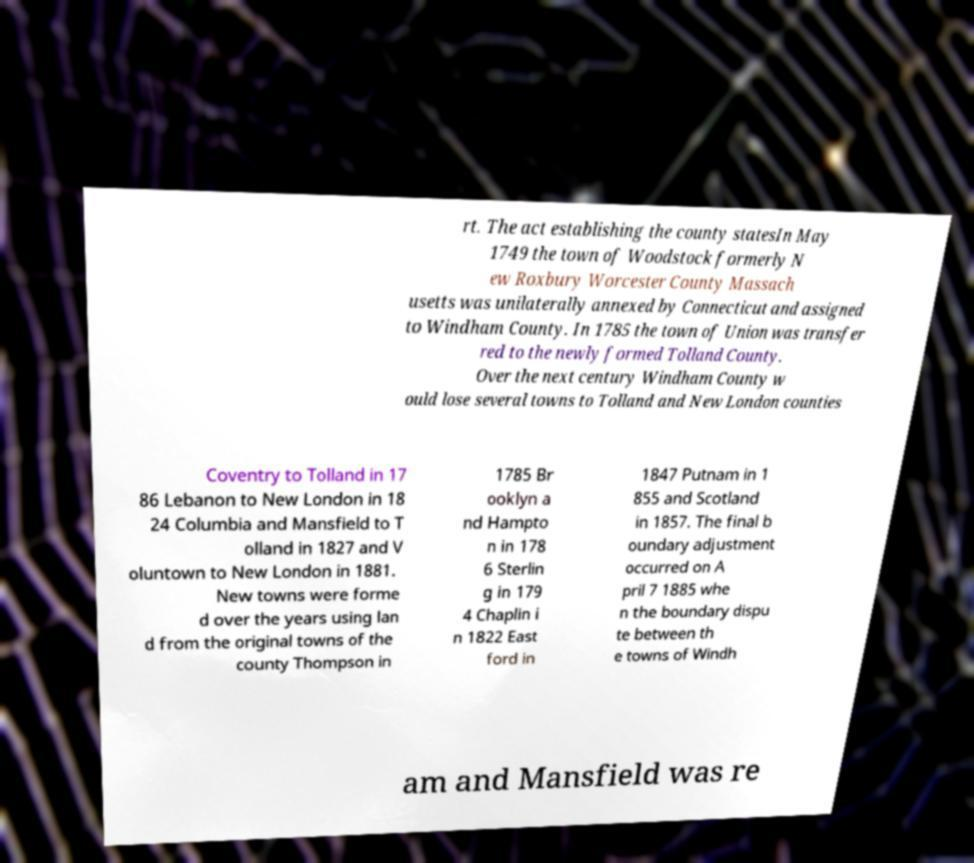I need the written content from this picture converted into text. Can you do that? rt. The act establishing the county statesIn May 1749 the town of Woodstock formerly N ew Roxbury Worcester County Massach usetts was unilaterally annexed by Connecticut and assigned to Windham County. In 1785 the town of Union was transfer red to the newly formed Tolland County. Over the next century Windham County w ould lose several towns to Tolland and New London counties Coventry to Tolland in 17 86 Lebanon to New London in 18 24 Columbia and Mansfield to T olland in 1827 and V oluntown to New London in 1881. New towns were forme d over the years using lan d from the original towns of the county Thompson in 1785 Br ooklyn a nd Hampto n in 178 6 Sterlin g in 179 4 Chaplin i n 1822 East ford in 1847 Putnam in 1 855 and Scotland in 1857. The final b oundary adjustment occurred on A pril 7 1885 whe n the boundary dispu te between th e towns of Windh am and Mansfield was re 